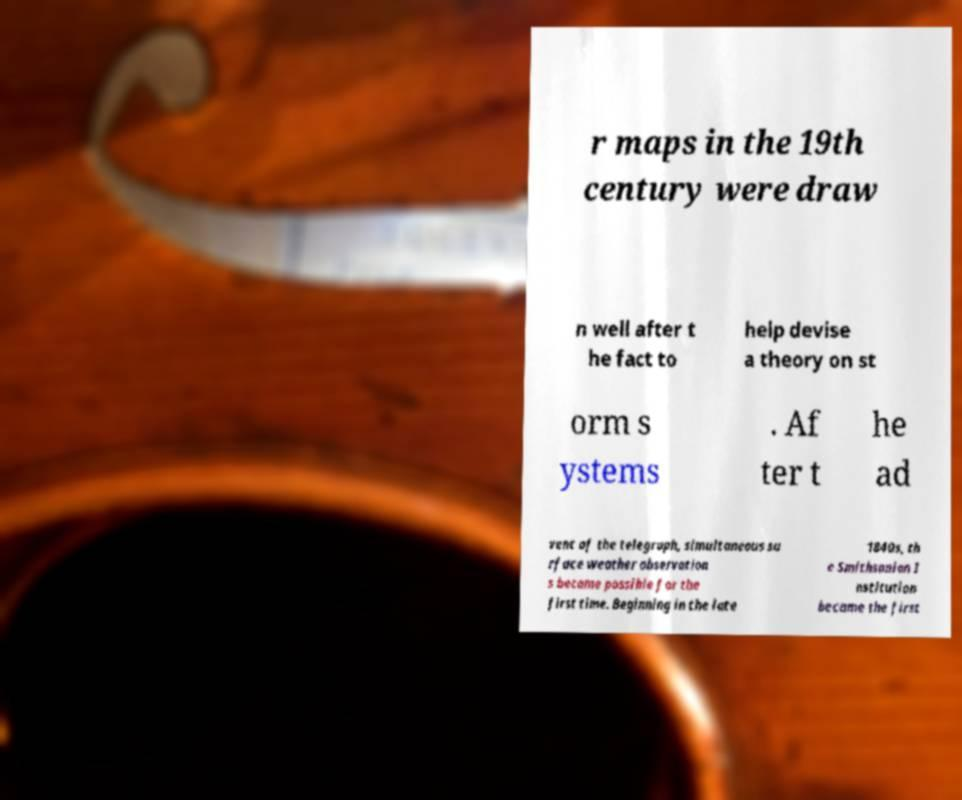Please read and relay the text visible in this image. What does it say? r maps in the 19th century were draw n well after t he fact to help devise a theory on st orm s ystems . Af ter t he ad vent of the telegraph, simultaneous su rface weather observation s became possible for the first time. Beginning in the late 1840s, th e Smithsonian I nstitution became the first 